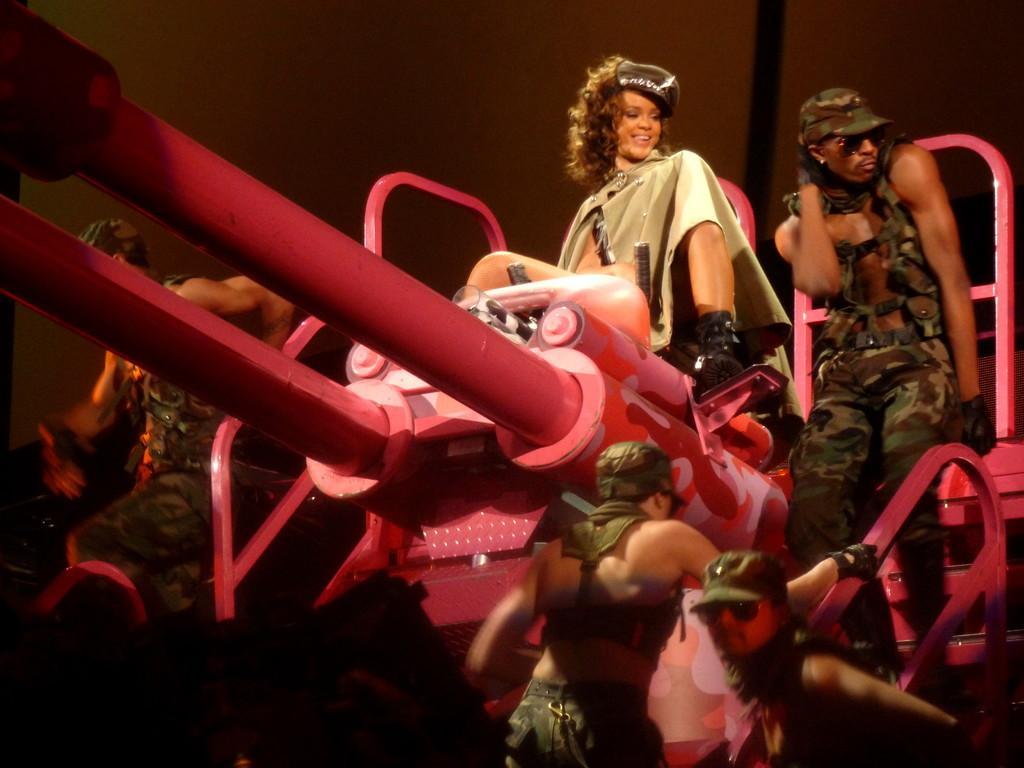Can you describe this image briefly? In this image, we can see a woman sitting and we can see some people. 